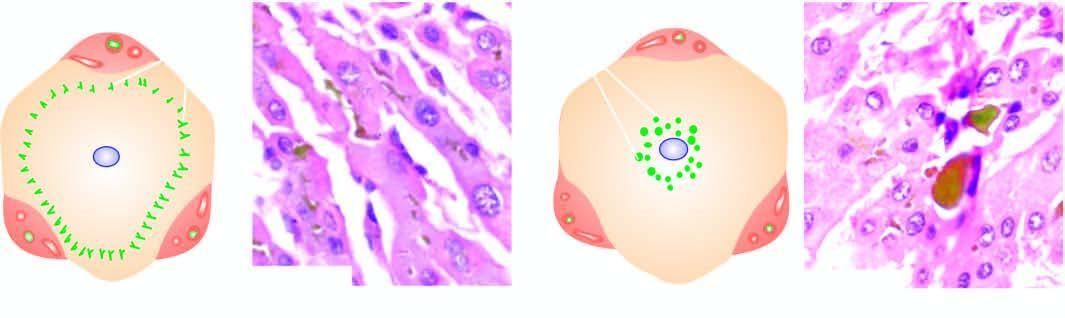do many of the hepatocytes show characteristic bile lakes due to rupture of canaliculi in the hepatocytes in the centrilobular area?
Answer the question using a single word or phrase. No 